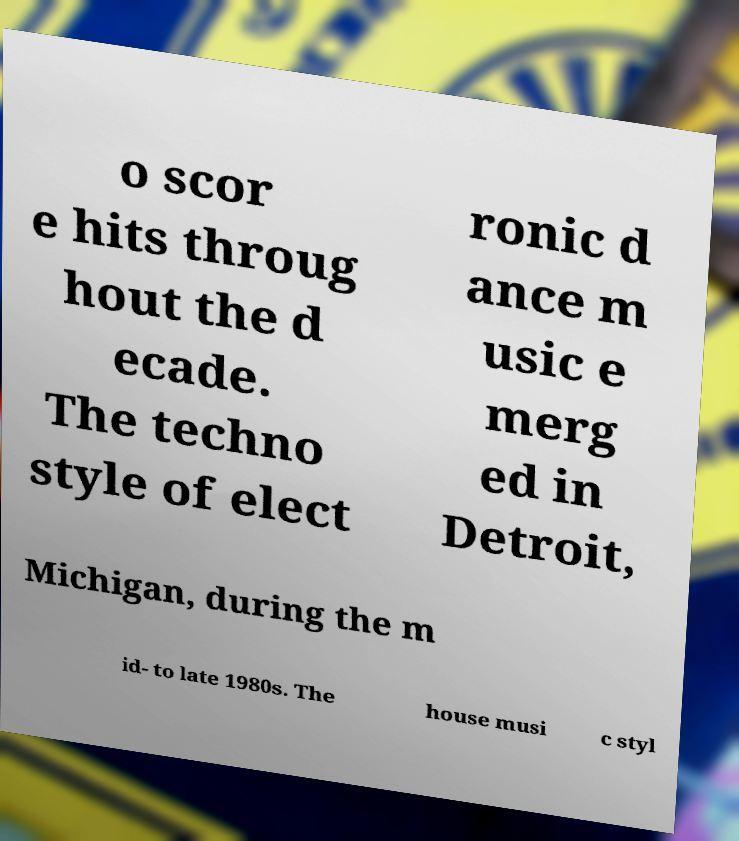Could you assist in decoding the text presented in this image and type it out clearly? o scor e hits throug hout the d ecade. The techno style of elect ronic d ance m usic e merg ed in Detroit, Michigan, during the m id- to late 1980s. The house musi c styl 